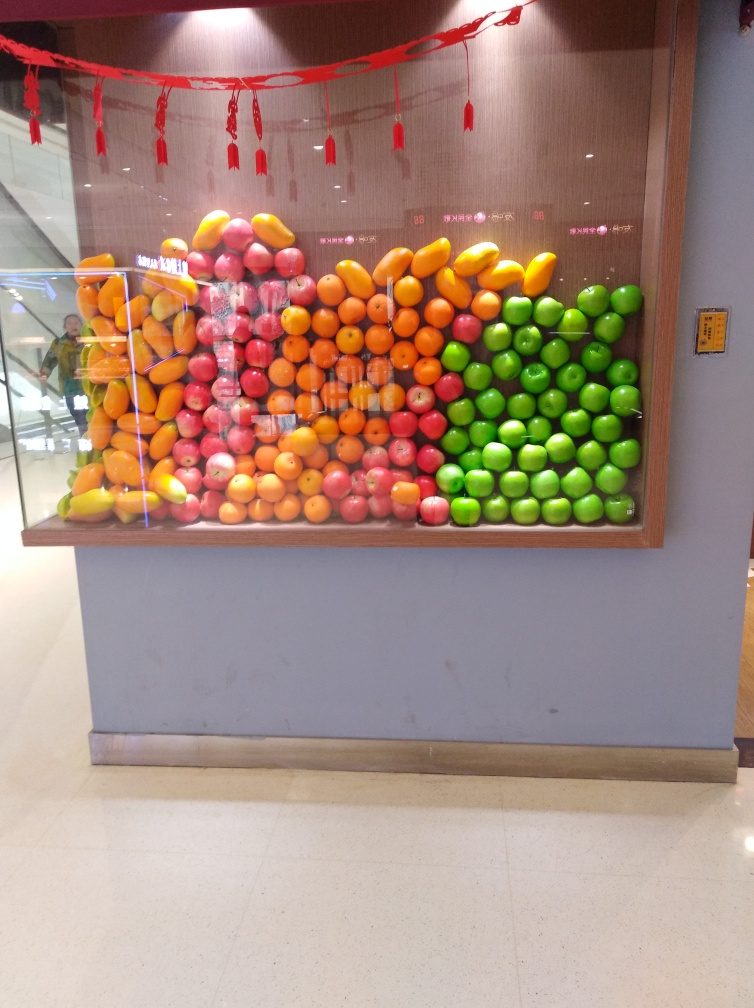Are there any people or man-made object in the image besides the fruit display? Yes, in the background there is a reflection that suggests the presence of people. Additionally, there is a red ribbon at the top of the arrangement, which is a man-made object, and likely part of the display setup. Can you tell me more about the setting? The setting appears to be indoors, possibly within a commercial space such as a shopping mall or a store, deduced from the tiled floor, the ambient lighting, and the modern aesthetic of the surroundings. The fruit display is positioned against a wooden backdrop with a decorative element, further implying a thoughtfully arranged venue. 